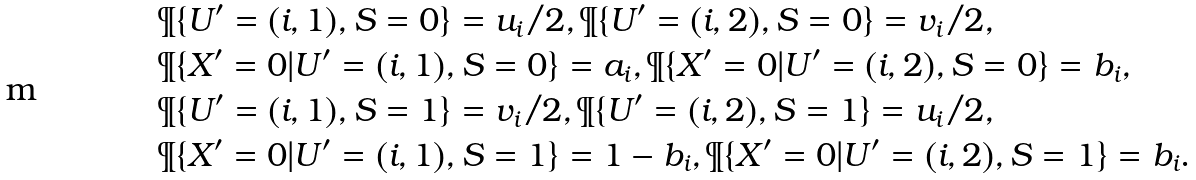<formula> <loc_0><loc_0><loc_500><loc_500>& \P \{ U ^ { \prime } = ( i , 1 ) , S = 0 \} = u _ { i } / 2 , \P \{ U ^ { \prime } = ( i , 2 ) , S = 0 \} = v _ { i } / 2 , \\ & \P \{ X ^ { \prime } = 0 | U ^ { \prime } = ( i , 1 ) , S = 0 \} = a _ { i } , \P \{ X ^ { \prime } = 0 | U ^ { \prime } = ( i , 2 ) , S = 0 \} = b _ { i } , \\ & \P \{ U ^ { \prime } = ( i , 1 ) , S = 1 \} = v _ { i } / 2 , \P \{ U ^ { \prime } = ( i , 2 ) , S = 1 \} = u _ { i } / 2 , \\ & \P \{ X ^ { \prime } = 0 | U ^ { \prime } = ( i , 1 ) , S = 1 \} = 1 - b _ { i } , \P \{ X ^ { \prime } = 0 | U ^ { \prime } = ( i , 2 ) , S = 1 \} = b _ { i } .</formula> 